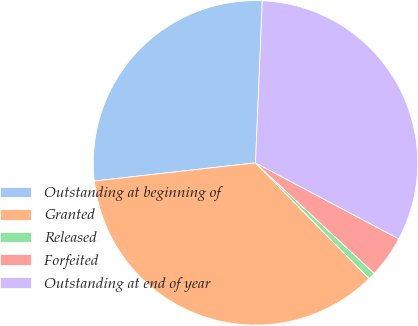Convert chart. <chart><loc_0><loc_0><loc_500><loc_500><pie_chart><fcel>Outstanding at beginning of<fcel>Granted<fcel>Released<fcel>Forfeited<fcel>Outstanding at end of year<nl><fcel>27.45%<fcel>35.56%<fcel>0.72%<fcel>4.17%<fcel>32.1%<nl></chart> 